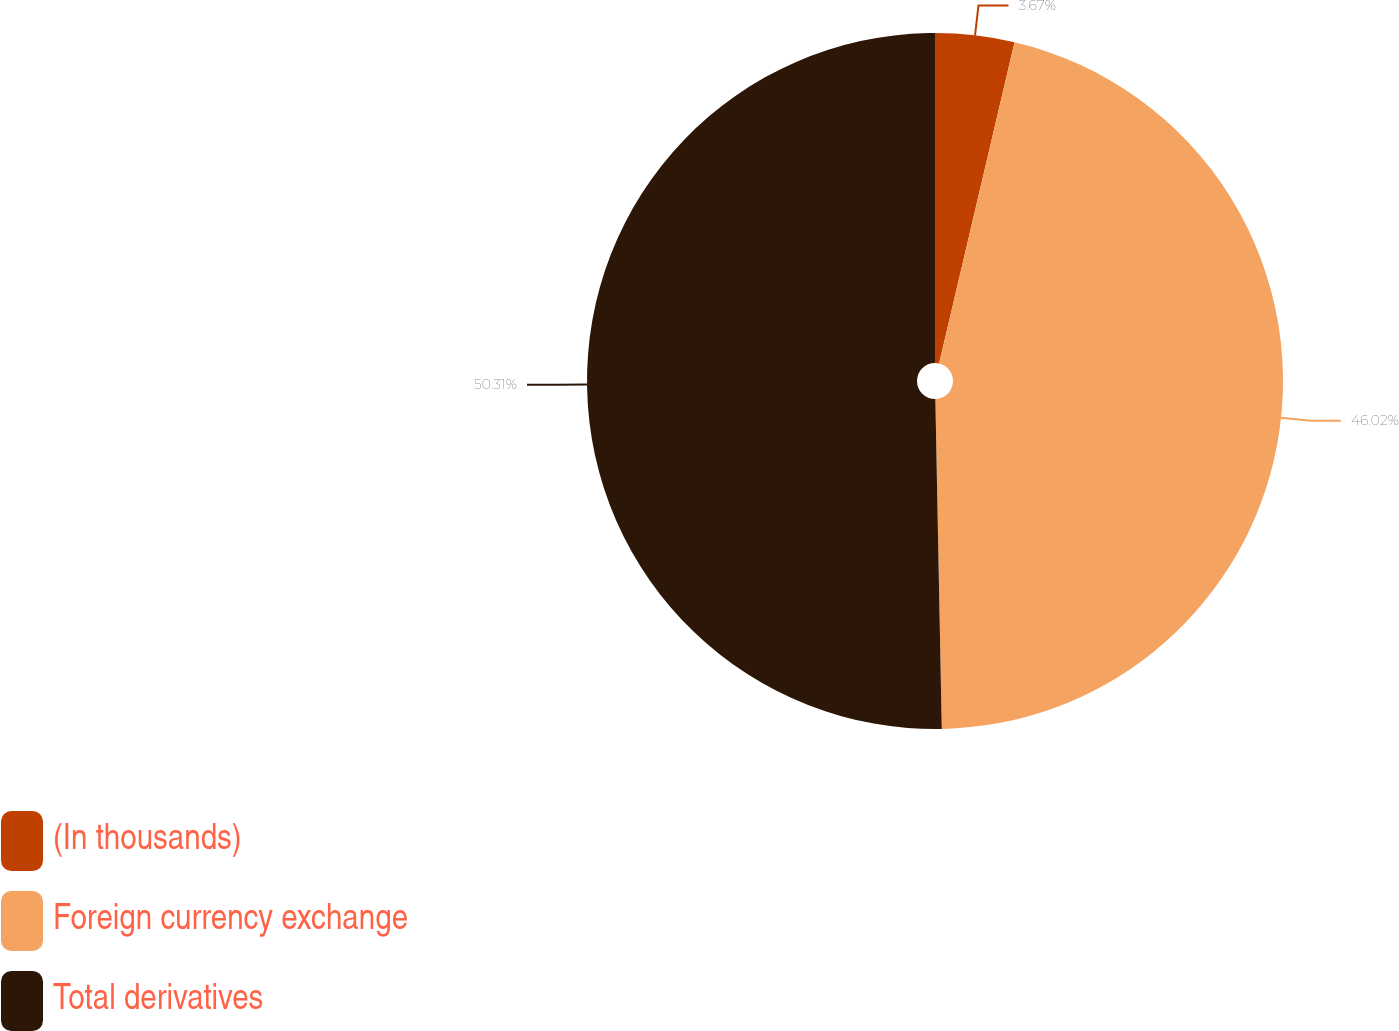Convert chart. <chart><loc_0><loc_0><loc_500><loc_500><pie_chart><fcel>(In thousands)<fcel>Foreign currency exchange<fcel>Total derivatives<nl><fcel>3.67%<fcel>46.02%<fcel>50.31%<nl></chart> 